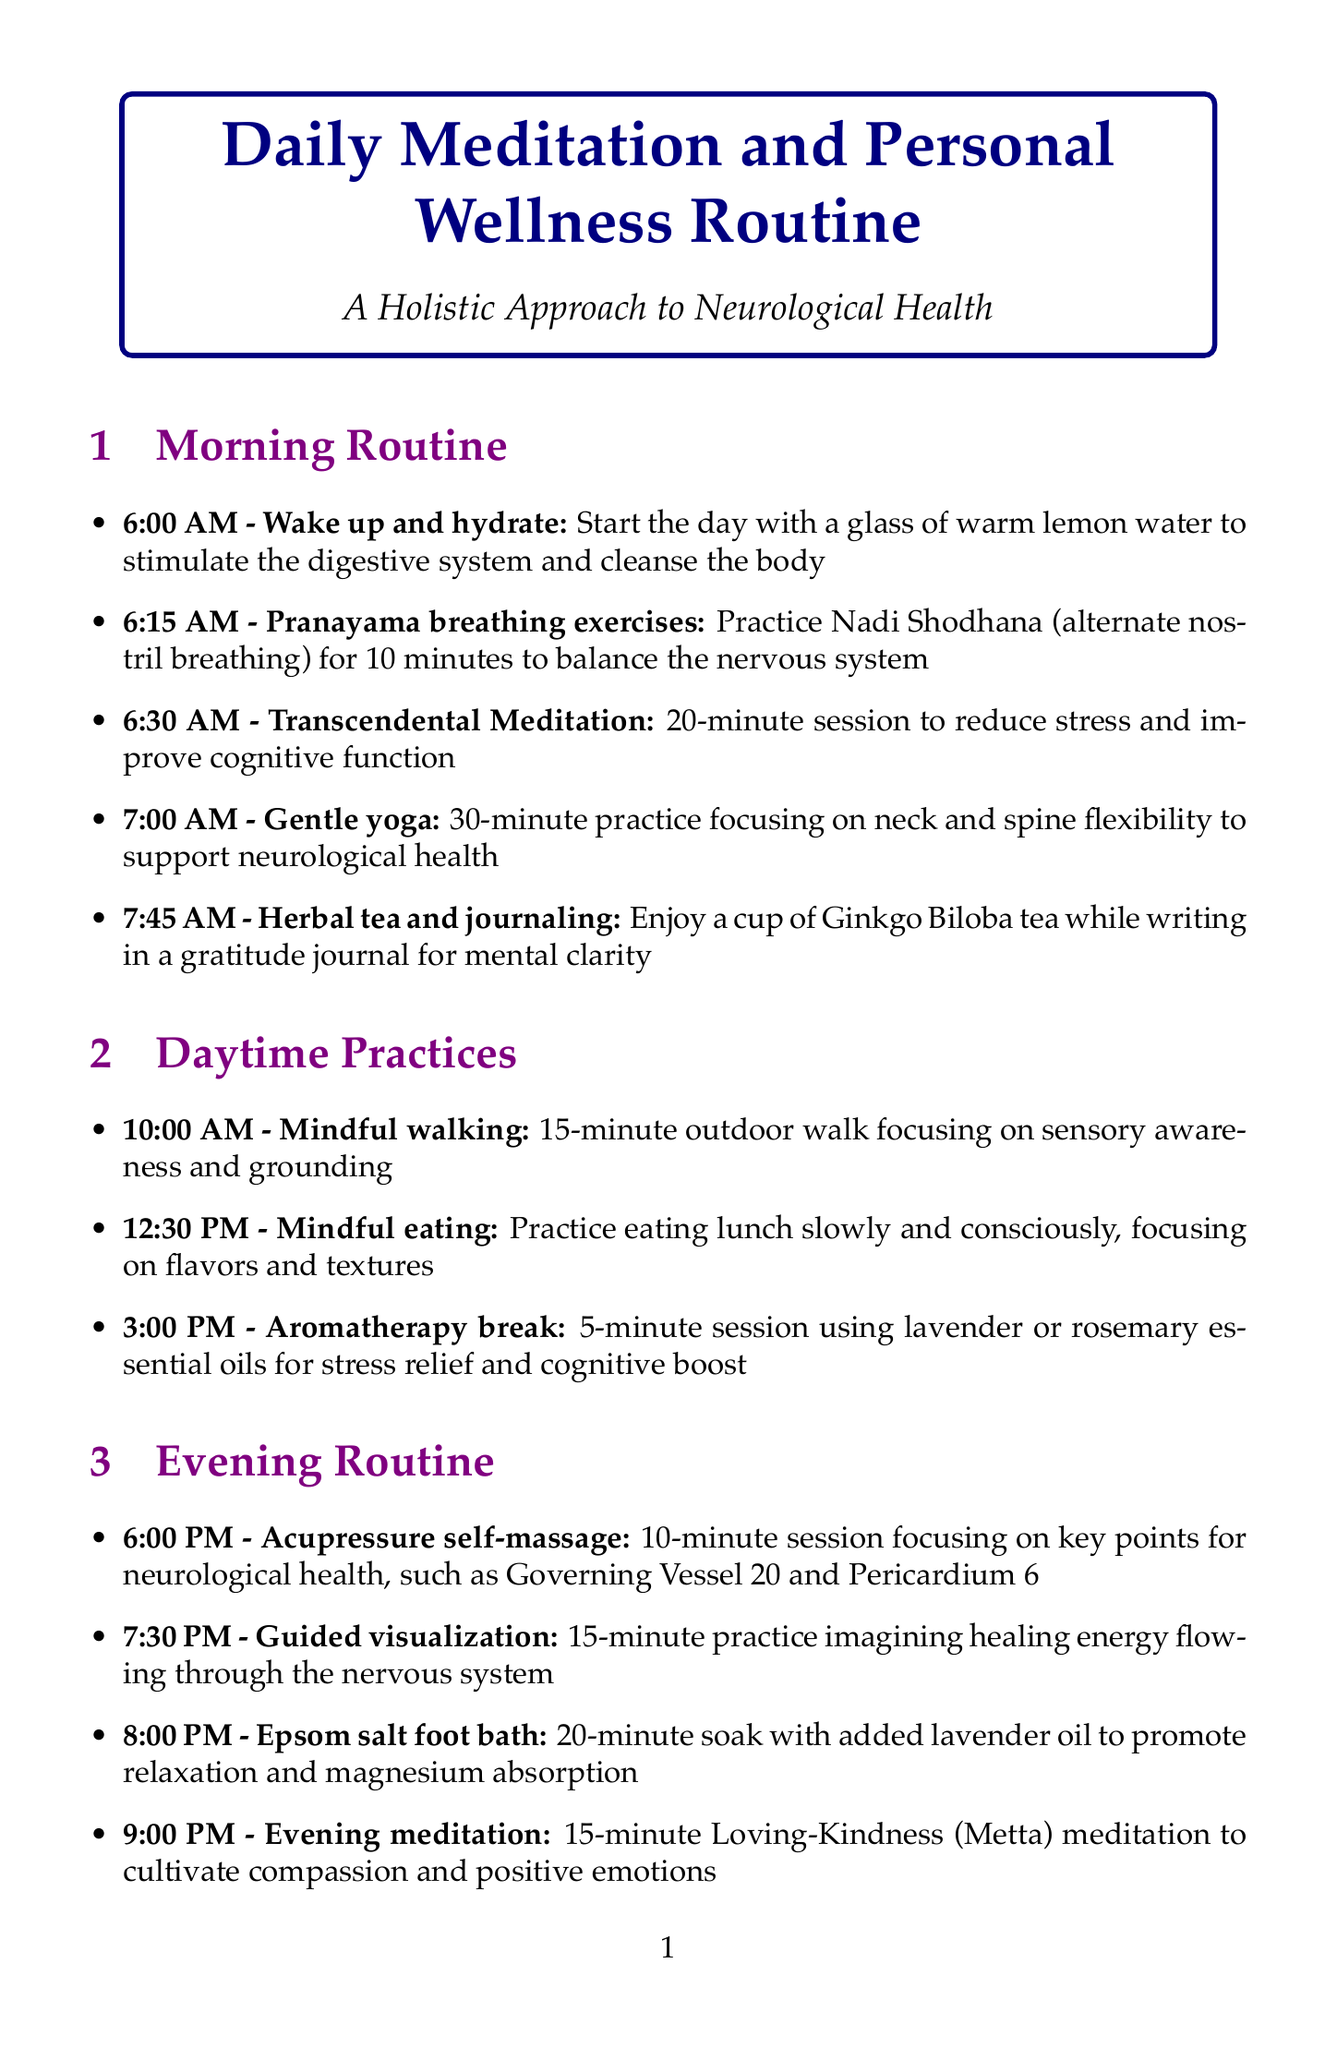what time does the evening meditation start? The evening meditation is scheduled for 9:00 PM in the document.
Answer: 9:00 PM how long is the Transcendental Meditation session? The Transcendental Meditation session lasts for 20 minutes as stated in the morning routine.
Answer: 20 minutes what activity is scheduled for 10:00 AM? The activity scheduled for 10:00 AM is mindful walking, which is a 15-minute outdoor walk.
Answer: Mindful walking which day is the Qigong session scheduled? The Qigong session is scheduled for Monday, as noted in the weekly practices.
Answer: Monday how many minutes is the Epsom salt foot bath? The Epsom salt foot bath lasts for 20 minutes according to the evening routine.
Answer: 20 minutes what is the main focus of the gentle yoga session? The gentle yoga session focuses on neck and spine flexibility to support neurological health.
Answer: Neck and spine flexibility what is the length of the sound healing session? The sound healing session lasts for 30 minutes as described in the weekly practices.
Answer: 30 minutes how often should the Ayurvedic consultation be done? Ayurvedic consultation is listed as a monthly practice, indicating it should be done once a month.
Answer: Monthly what is the second activity in the morning routine? The second activity in the morning routine is Pranayama breathing exercises at 6:15 AM.
Answer: Pranayama breathing exercises 